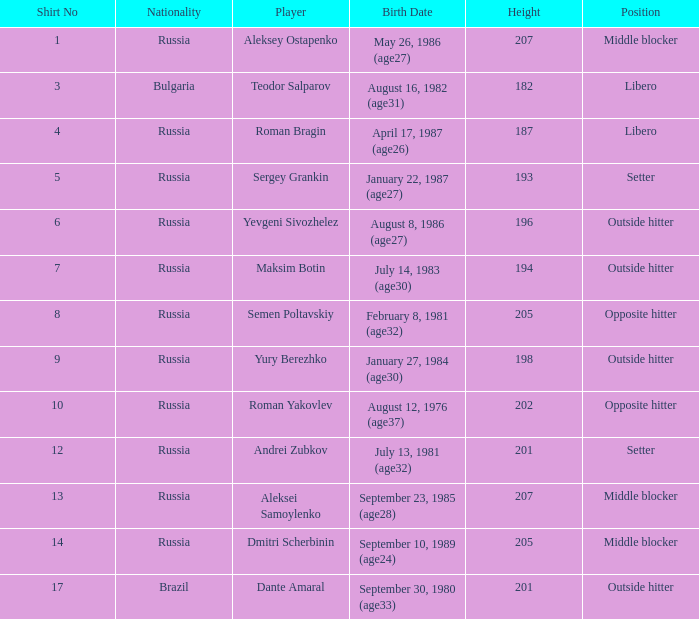How tall is Maksim Botin?  194.0. 